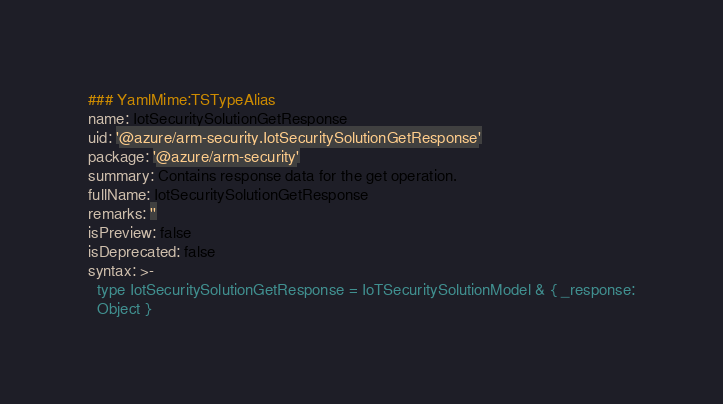Convert code to text. <code><loc_0><loc_0><loc_500><loc_500><_YAML_>### YamlMime:TSTypeAlias
name: IotSecuritySolutionGetResponse
uid: '@azure/arm-security.IotSecuritySolutionGetResponse'
package: '@azure/arm-security'
summary: Contains response data for the get operation.
fullName: IotSecuritySolutionGetResponse
remarks: ''
isPreview: false
isDeprecated: false
syntax: >-
  type IotSecuritySolutionGetResponse = IoTSecuritySolutionModel & { _response:
  Object }
</code> 